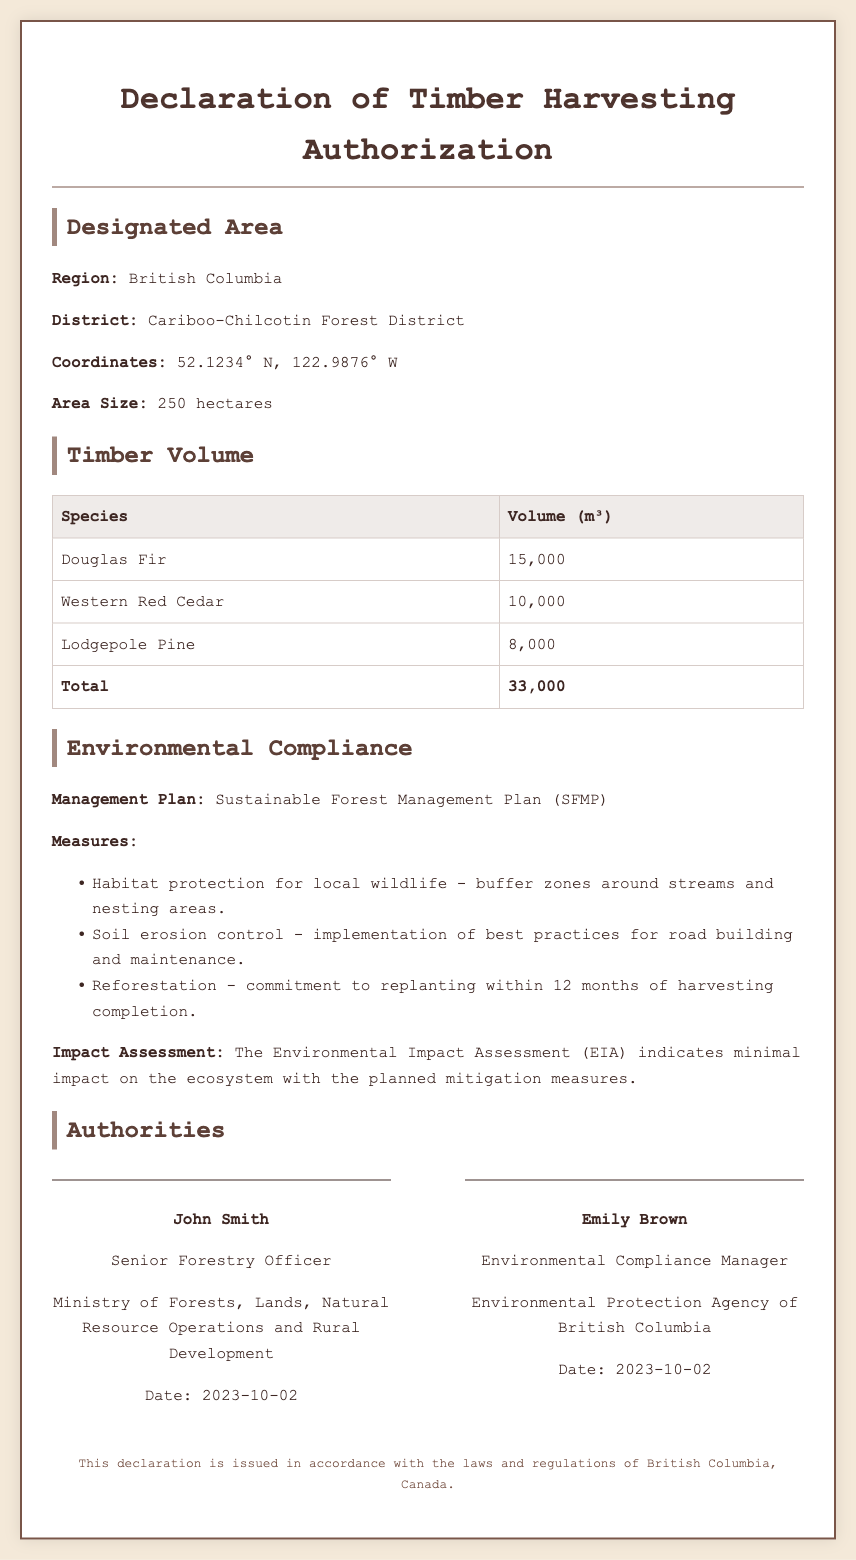What is the designated region for logging? The document states that the designated region for logging is British Columbia.
Answer: British Columbia What is the area size designated for logging? The document specifies that the area size is 250 hectares.
Answer: 250 hectares What is the total volume of timber to be harvested? The total volume of timber to be harvested, as listed in the document, is 33,000 m³.
Answer: 33,000 m³ Who is the Senior Forestry Officer? The document identifies John Smith as the Senior Forestry Officer.
Answer: John Smith What is the habitat protection measure mentioned? The document mentions buffer zones around streams and nesting areas as a habitat protection measure.
Answer: buffer zones around streams and nesting areas What species of timber has the highest volume? According to the document, Douglas Fir has the highest volume among the listed species.
Answer: Douglas Fir What is the commitment for reforestation mentioned in the document? The document states there is a commitment to replanting within 12 months of harvesting completion.
Answer: within 12 months of harvesting completion What date was the declaration signed? The document indicates that the declaration was signed on October 2, 2023.
Answer: 2023-10-02 What is the title of Emily Brown? The document states that Emily Brown holds the title of Environmental Compliance Manager.
Answer: Environmental Compliance Manager 